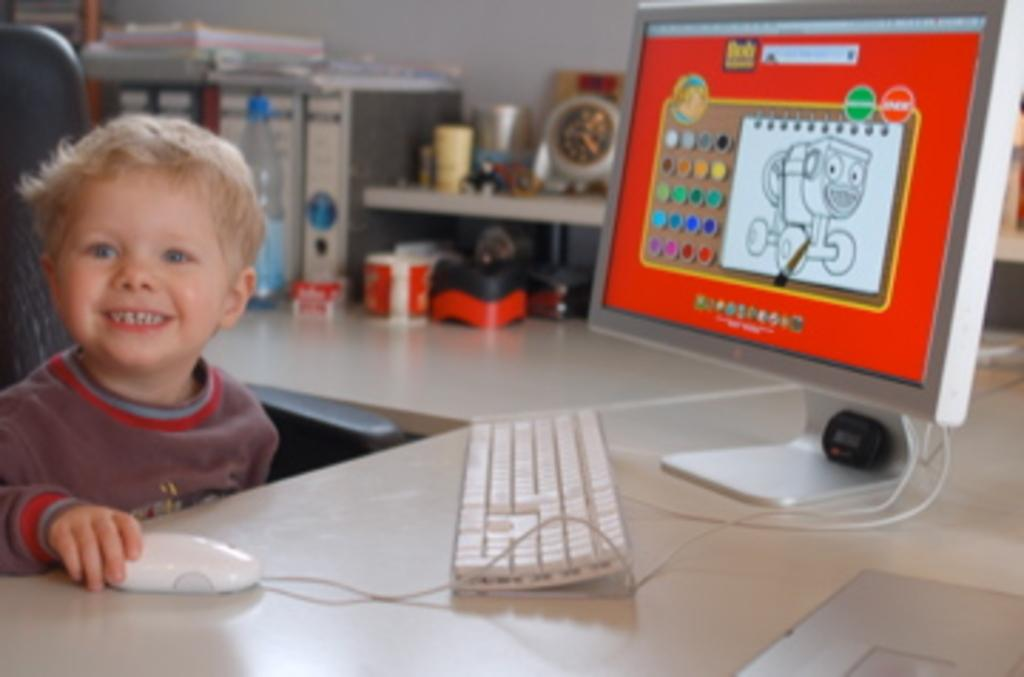What is the facial expression of the person in the image? The person in the image is smiling. What object is the person holding in the image? The person is holding a mouse, likely a computer mouse. What piece of furniture is present in the image? There is a table in the image. What electronic devices are on the table? There is a computer system and a keyboard on the table. What additional object can be seen on the table? There is a bottle on the table. Can you see a toad hopping in the image? No, there is no toad present in the image. Is there a rainstorm happening in the image? No, there is no rainstorm depicted in the image. 